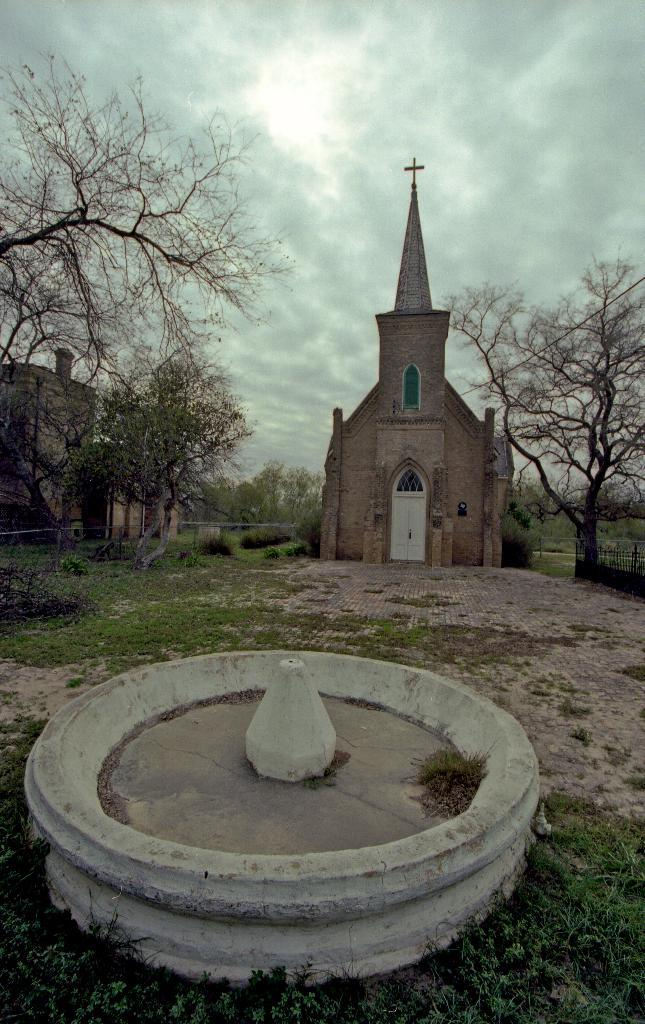What type of vegetation can be seen in the image? There is grass, plants, and trees in the image. What type of structures are present in the image? There are buildings in the image. What is the condition of the fountain in the image? The fountain in the image does not have water. What is visible in the background of the image? There is sky visible in the background of the image. What can be seen in the sky? There are clouds in the sky. What type of twist can be seen in the middle of the image? There is no twist present in the image. What is the kettle used for in the image? There is no kettle present in the image. 